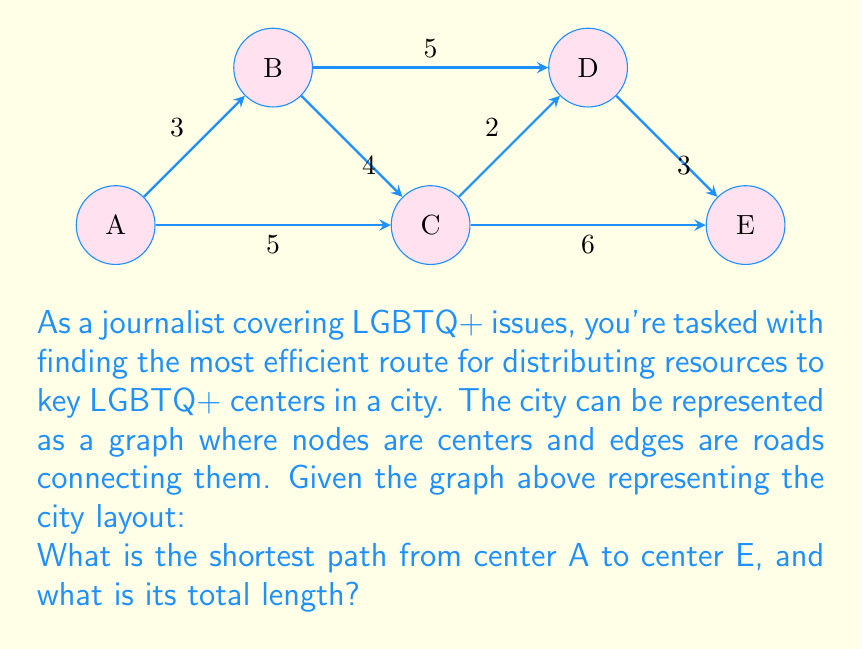Provide a solution to this math problem. To solve this problem, we can use Dijkstra's algorithm to find the shortest path from A to E. Let's go through the steps:

1) Initialize:
   - Distance to A = 0
   - Distance to all other nodes = infinity
   - Set of unvisited nodes = {A, B, C, D, E}

2) From A:
   - Update distances: B = 3, C = 5
   - Select C (shorter distance)
   - Unvisited = {B, D, E}

3) From C:
   - Update distances: B = min(3, 5+4) = 3, D = 5+2 = 7, E = 5+6 = 11
   - Select B (shortest distance)
   - Unvisited = {D, E}

4) From B:
   - Update distances: D = min(7, 3+5) = 7
   - Select D (shortest distance)
   - Unvisited = {E}

5) From D:
   - Update distance: E = min(11, 7+3) = 10
   - Select E (only remaining node)
   - Unvisited = {}

The shortest path is therefore A → C → D → E with a total length of 5 + 2 + 3 = 10.
Answer: A → C → D → E, length 10 